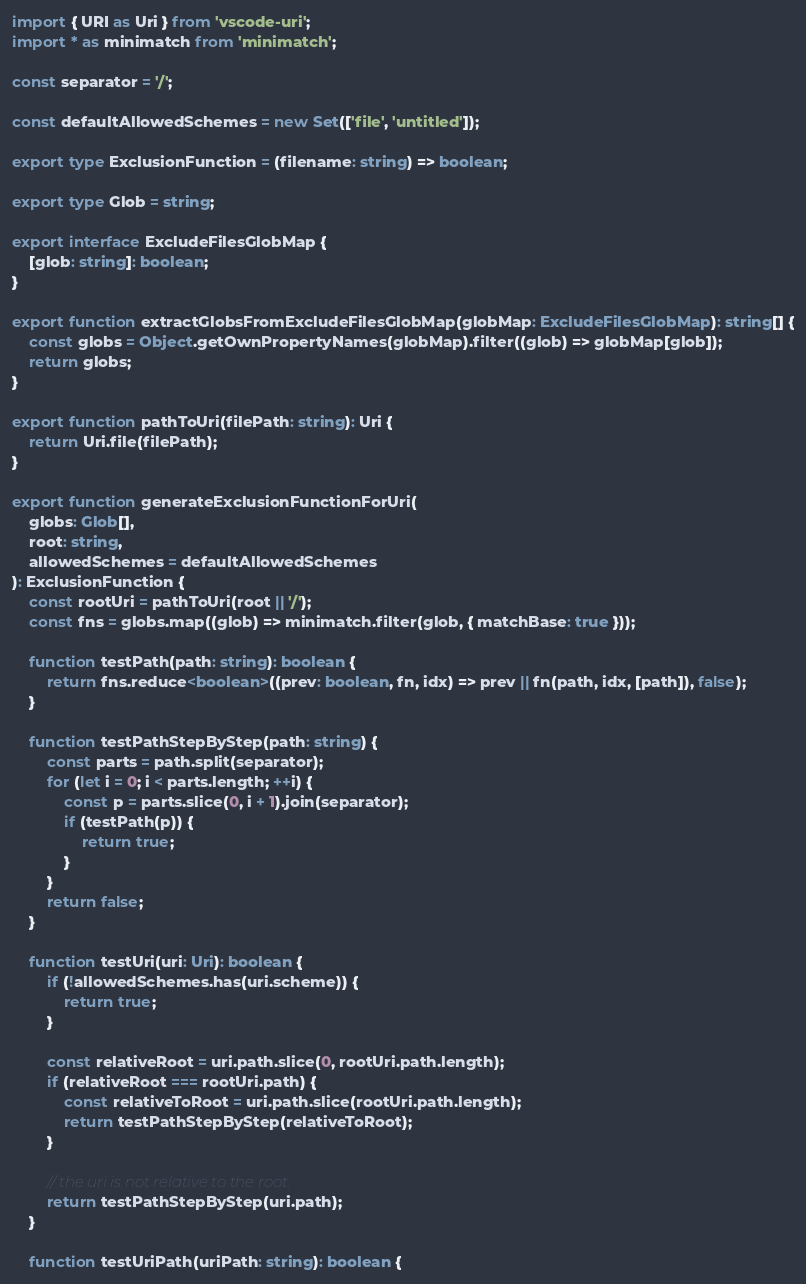Convert code to text. <code><loc_0><loc_0><loc_500><loc_500><_TypeScript_>import { URI as Uri } from 'vscode-uri';
import * as minimatch from 'minimatch';

const separator = '/';

const defaultAllowedSchemes = new Set(['file', 'untitled']);

export type ExclusionFunction = (filename: string) => boolean;

export type Glob = string;

export interface ExcludeFilesGlobMap {
    [glob: string]: boolean;
}

export function extractGlobsFromExcludeFilesGlobMap(globMap: ExcludeFilesGlobMap): string[] {
    const globs = Object.getOwnPropertyNames(globMap).filter((glob) => globMap[glob]);
    return globs;
}

export function pathToUri(filePath: string): Uri {
    return Uri.file(filePath);
}

export function generateExclusionFunctionForUri(
    globs: Glob[],
    root: string,
    allowedSchemes = defaultAllowedSchemes
): ExclusionFunction {
    const rootUri = pathToUri(root || '/');
    const fns = globs.map((glob) => minimatch.filter(glob, { matchBase: true }));

    function testPath(path: string): boolean {
        return fns.reduce<boolean>((prev: boolean, fn, idx) => prev || fn(path, idx, [path]), false);
    }

    function testPathStepByStep(path: string) {
        const parts = path.split(separator);
        for (let i = 0; i < parts.length; ++i) {
            const p = parts.slice(0, i + 1).join(separator);
            if (testPath(p)) {
                return true;
            }
        }
        return false;
    }

    function testUri(uri: Uri): boolean {
        if (!allowedSchemes.has(uri.scheme)) {
            return true;
        }

        const relativeRoot = uri.path.slice(0, rootUri.path.length);
        if (relativeRoot === rootUri.path) {
            const relativeToRoot = uri.path.slice(rootUri.path.length);
            return testPathStepByStep(relativeToRoot);
        }

        // the uri is not relative to the root.
        return testPathStepByStep(uri.path);
    }

    function testUriPath(uriPath: string): boolean {</code> 